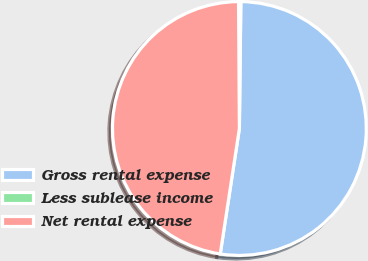<chart> <loc_0><loc_0><loc_500><loc_500><pie_chart><fcel>Gross rental expense<fcel>Less sublease income<fcel>Net rental expense<nl><fcel>52.23%<fcel>0.29%<fcel>47.48%<nl></chart> 